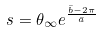Convert formula to latex. <formula><loc_0><loc_0><loc_500><loc_500>s = \theta _ { \infty } e ^ { \frac { \bar { b } - 2 \pi } { \bar { a } } }</formula> 